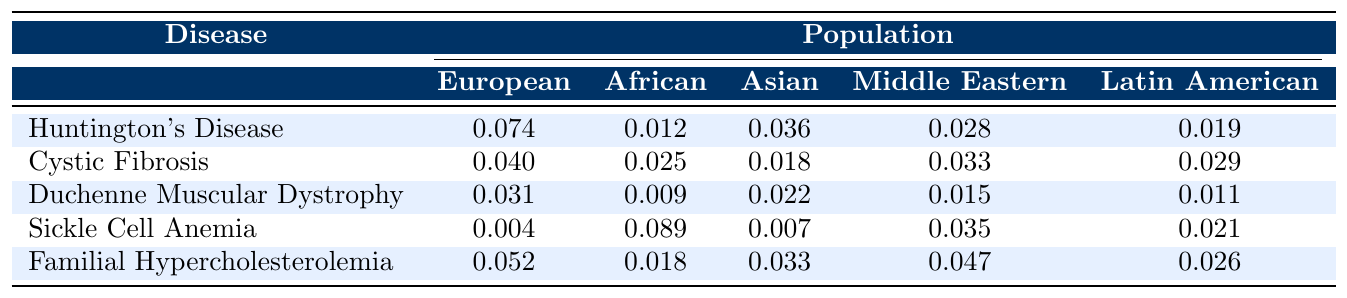What is the mutation associated with Huntington's Disease? Huntington's Disease is associated with the CAG trinucleotide repeat expansion mutation, which is mentioned in the data provided.
Answer: CAG trinucleotide repeat expansion Which population shows the highest prevalence of Sickle Cell Anemia? Looking at the values for Sickle Cell Anemia across different populations, the African population has the highest prevalence at 0.089.
Answer: African What is the average prevalence of Cystic Fibrosis across all populations? To find the average, add up the values (0.040 + 0.025 + 0.018 + 0.033 + 0.029 = 0.175) and divide by the number of populations (5), the average is 0.175 / 5 = 0.035.
Answer: 0.035 Is the prevalence of Duchenne Muscular Dystrophy higher in Asian populations compared to Latin American populations? The prevalence for Duchenne Muscular Dystrophy in the Asian population is 0.022 and in the Latin American population is 0.011. Since 0.022 is greater than 0.011, the statement is true.
Answer: Yes What is the difference in prevalence of Familial Hypercholesterolemia between the African and Middle Eastern populations? The prevalence for Familial Hypercholesterolemia in the African population is 0.018 and in the Middle Eastern population is 0.047. The difference is calculated as 0.047 - 0.018 = 0.029.
Answer: 0.029 Which disease has the lowest prevalence in the European population? By inspecting the table, Sickle Cell Anemia has the lowest prevalence in the European population at 0.004.
Answer: Sickle Cell Anemia What is the total sample size for all populations combined for Huntington's Disease? The sample sizes for Huntington's Disease across all populations are 10000, 8000, 12000, 6000, and 9000. Adding these gives a total sample size of 10000 + 8000 + 12000 + 6000 + 9000 = 44000.
Answer: 44000 Which genetic mutation has the lowest prevalence in the Middle Eastern population? The Middle Eastern prevalence for each genetic mutation is 0.028, 0.033, 0.015, 0.035, and 0.047 for the respective diseases. The lowest value is 0.015 for Duchenne Muscular Dystrophy.
Answer: Duchenne Muscular Dystrophy How does the prevalence of the Delta F508 mutation in Cystic Fibrosis compare to the prevalence of the HbS allele in Sickle Cell Anemia in the African population? The prevalence for the Delta F508 mutation in Cystic Fibrosis is 0.025 and for the HbS allele in Sickle Cell Anemia is 0.089 in the African population. Since 0.025 is less than 0.089, the Delta F508 mutation has a lower prevalence.
Answer: Delta F508 mutation is lower What is the confidence interval for the prevalence of Huntington's Disease? The confidence interval for Huntington's Disease is listed as (0.069, 0.079).
Answer: (0.069, 0.079) 